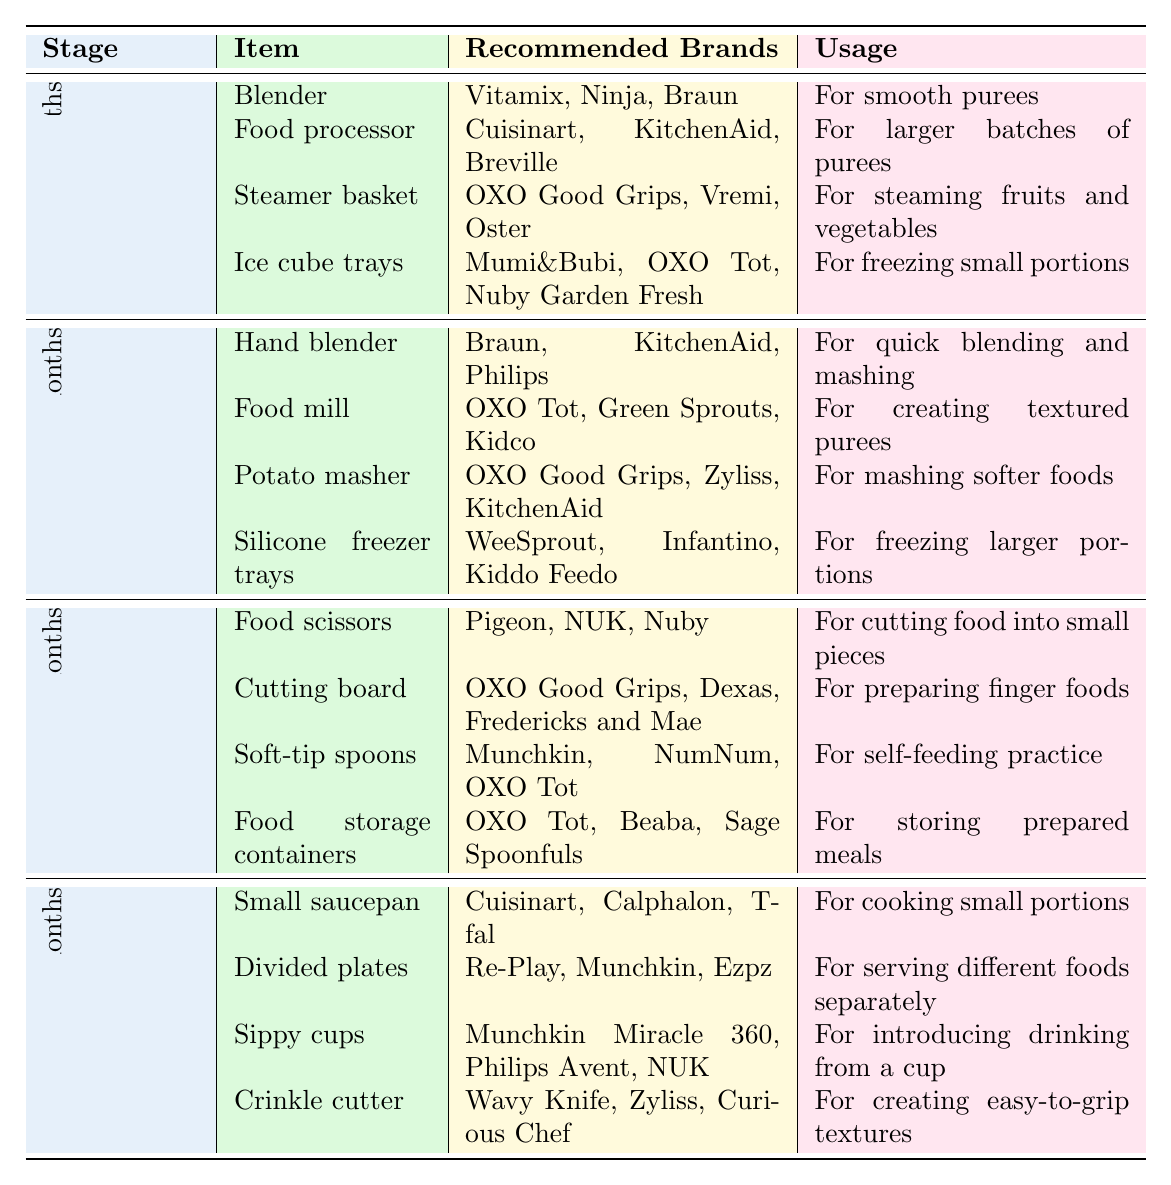What equipment is essential for preparing purees at 4-6 months? According to the table, four items are essential for this stage: Blender, Food processor, Steamer basket, and Ice cube trays.
Answer: Blender, Food processor, Steamer basket, Ice cube trays Which recommended brand is listed for the food mill used from 6-8 months? The table lists OXO Tot, Green Sprouts, and Kidco as recommended brands for the food mill.
Answer: OXO Tot, Green Sprouts, Kidco Is a hand blender recommended for the 8-10 months stage? Yes, the table indicates that a hand blender is an essential equipment for the 6-8 months stage, not for 8-10 months.
Answer: No How many essential equipment items are listed for the 10-12 months stage? The table specifies four items for the 10-12 months stage: Small saucepan, Divided plates, Sippy cups, and Crinkle cutter.
Answer: Four Which equipment is used for creating easy-to-grip textures at 10-12 months? From the table, the Crinkle cutter is designated for creating easy-to-grip textures at this stage.
Answer: Crinkle cutter List the recommended brands for Soft-tip spoons at 8-10 months. The table shows Munchkin, NumNum, and OXO Tot as the recommended brands for Soft-tip spoons.
Answer: Munchkin, NumNum, OXO Tot What is the primary usage of silicone freezer trays at 6-8 months? According to the table, silicone freezer trays are used for freezing larger portions.
Answer: Freezing larger portions Which piece of equipment has the same purpose as the hand blender? In the table, a potato masher can serve a similar purpose for mashing, but the hand blender is specifically for quick blending and mashing.
Answer: None (specific to quick blending and mashing) If I want to store prepared meals at 8-10 months, what equipment should I use? The table lists Food storage containers as the essential equipment for storing prepared meals at 8-10 months.
Answer: Food storage containers How does the number of essential items differ between the 4-6 months and 10-12 months stages? Both stages have four essential items, so there is no difference in the number of items.
Answer: No difference Which equipment is essential for self-feeding practice at 8-10 months? The table indicates that Soft-tip spoons are essential for self-feeding practice at this stage.
Answer: Soft-tip spoons Are ice cube trays recommended for any stage? Yes, the table states that ice cube trays are recommended for the 4-6 months stage for freezing small portions.
Answer: Yes How many brands are listed for the recommended equipment at 6-8 months? There are three brands listed for each of the four essential items at this stage, leading to a total of 12 brands.
Answer: Twelve brands Which stage requires a cutting board for finger foods? The table shows that a cutting board is essential for the 8-10 months stage for preparing finger foods.
Answer: 8-10 months In total, how many different essential items are there across all stages combined? Adding the four items from each of the four stages (4 + 4 + 4 + 4), the total number of different essential items across all stages is 16.
Answer: 16 